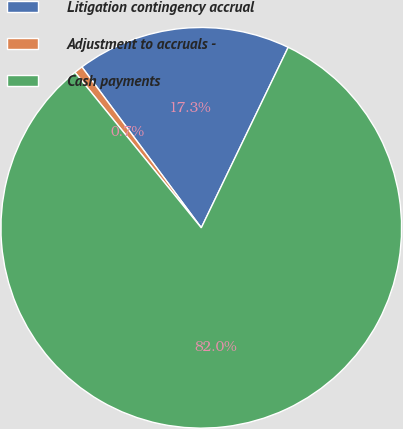<chart> <loc_0><loc_0><loc_500><loc_500><pie_chart><fcel>Litigation contingency accrual<fcel>Adjustment to accruals -<fcel>Cash payments<nl><fcel>17.3%<fcel>0.7%<fcel>82.0%<nl></chart> 